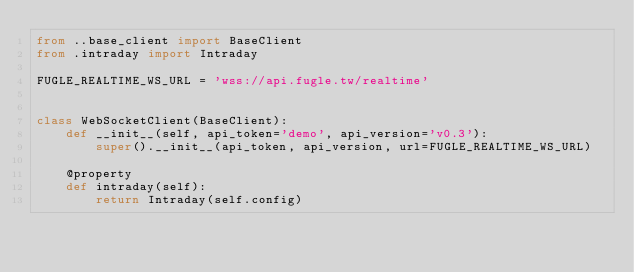<code> <loc_0><loc_0><loc_500><loc_500><_Python_>from ..base_client import BaseClient
from .intraday import Intraday

FUGLE_REALTIME_WS_URL = 'wss://api.fugle.tw/realtime'


class WebSocketClient(BaseClient):
    def __init__(self, api_token='demo', api_version='v0.3'):
        super().__init__(api_token, api_version, url=FUGLE_REALTIME_WS_URL)

    @property
    def intraday(self):
        return Intraday(self.config)
</code> 